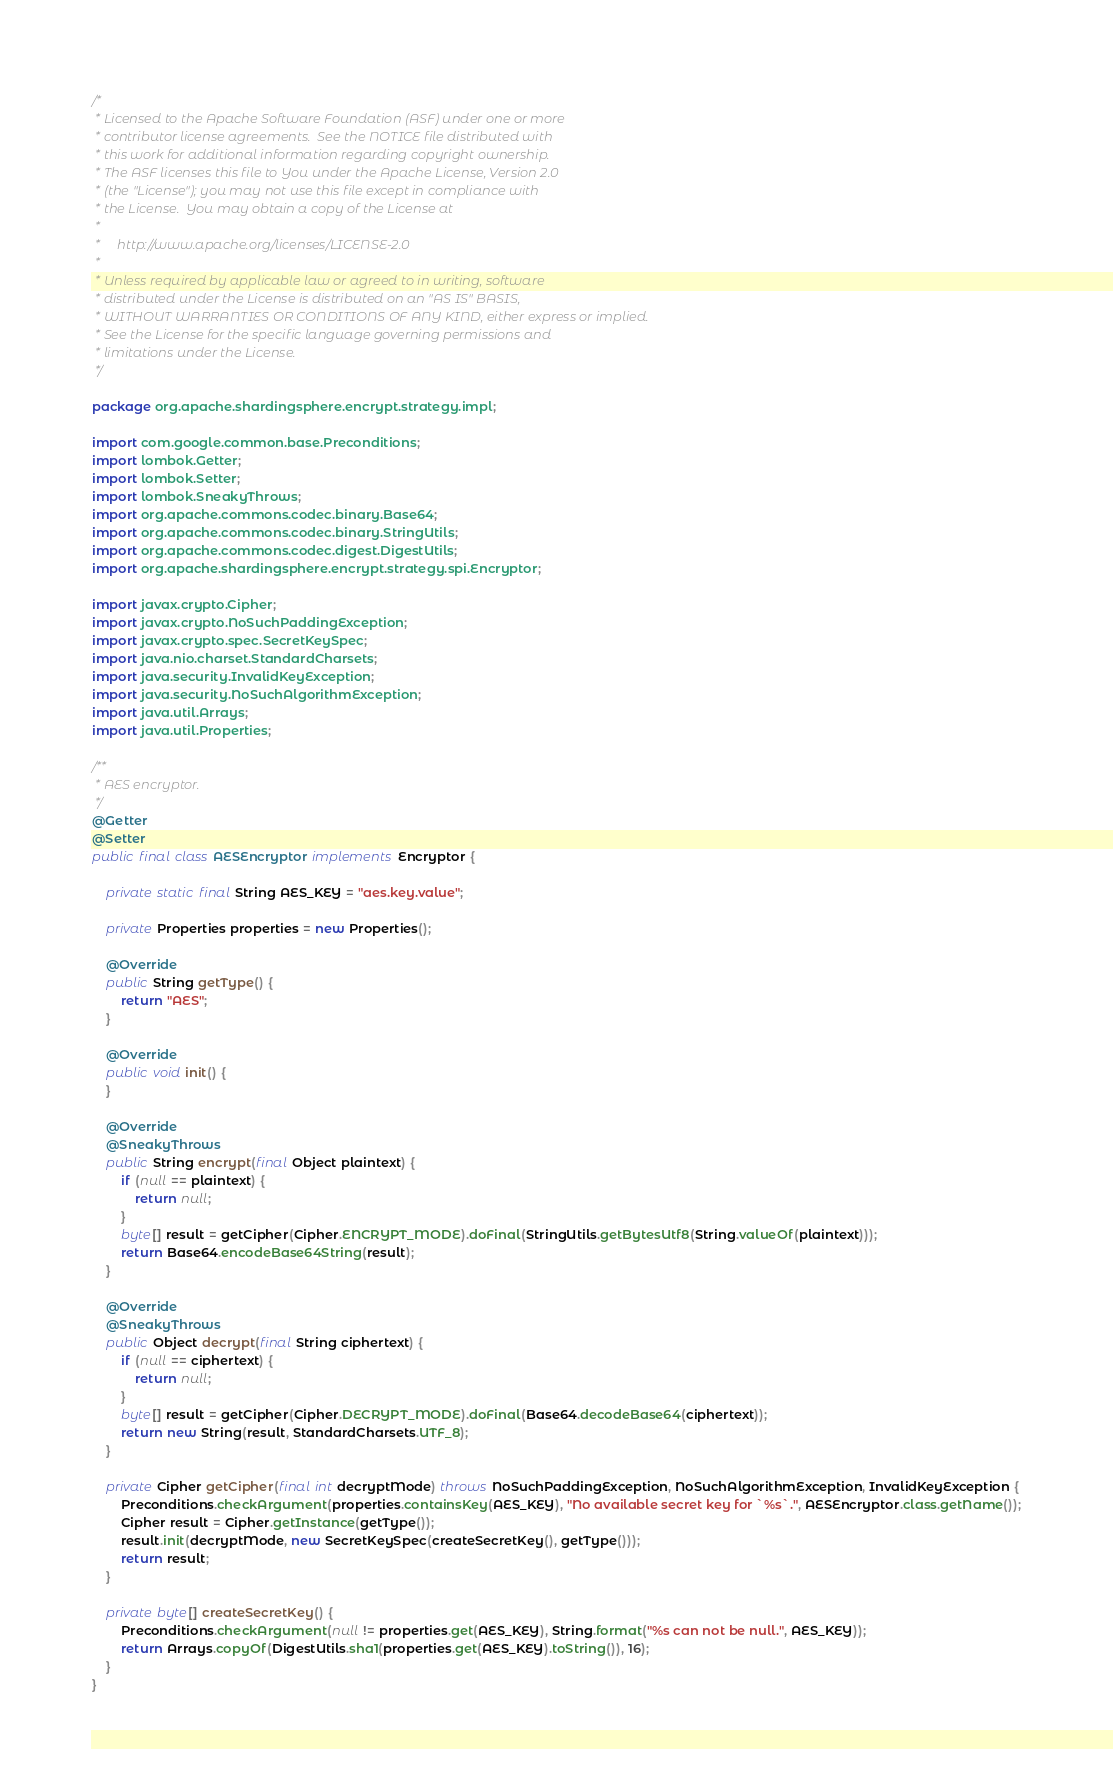Convert code to text. <code><loc_0><loc_0><loc_500><loc_500><_Java_>/*
 * Licensed to the Apache Software Foundation (ASF) under one or more
 * contributor license agreements.  See the NOTICE file distributed with
 * this work for additional information regarding copyright ownership.
 * The ASF licenses this file to You under the Apache License, Version 2.0
 * (the "License"); you may not use this file except in compliance with
 * the License.  You may obtain a copy of the License at
 *
 *     http://www.apache.org/licenses/LICENSE-2.0
 *
 * Unless required by applicable law or agreed to in writing, software
 * distributed under the License is distributed on an "AS IS" BASIS,
 * WITHOUT WARRANTIES OR CONDITIONS OF ANY KIND, either express or implied.
 * See the License for the specific language governing permissions and
 * limitations under the License.
 */

package org.apache.shardingsphere.encrypt.strategy.impl;

import com.google.common.base.Preconditions;
import lombok.Getter;
import lombok.Setter;
import lombok.SneakyThrows;
import org.apache.commons.codec.binary.Base64;
import org.apache.commons.codec.binary.StringUtils;
import org.apache.commons.codec.digest.DigestUtils;
import org.apache.shardingsphere.encrypt.strategy.spi.Encryptor;

import javax.crypto.Cipher;
import javax.crypto.NoSuchPaddingException;
import javax.crypto.spec.SecretKeySpec;
import java.nio.charset.StandardCharsets;
import java.security.InvalidKeyException;
import java.security.NoSuchAlgorithmException;
import java.util.Arrays;
import java.util.Properties;

/**
 * AES encryptor.
 */
@Getter
@Setter
public final class AESEncryptor implements Encryptor {

    private static final String AES_KEY = "aes.key.value";

    private Properties properties = new Properties();

    @Override
    public String getType() {
        return "AES";
    }

    @Override
    public void init() {
    }

    @Override
    @SneakyThrows
    public String encrypt(final Object plaintext) {
        if (null == plaintext) {
            return null;
        }
        byte[] result = getCipher(Cipher.ENCRYPT_MODE).doFinal(StringUtils.getBytesUtf8(String.valueOf(plaintext)));
        return Base64.encodeBase64String(result);
    }

    @Override
    @SneakyThrows
    public Object decrypt(final String ciphertext) {
        if (null == ciphertext) {
            return null;
        }
        byte[] result = getCipher(Cipher.DECRYPT_MODE).doFinal(Base64.decodeBase64(ciphertext));
        return new String(result, StandardCharsets.UTF_8);
    }

    private Cipher getCipher(final int decryptMode) throws NoSuchPaddingException, NoSuchAlgorithmException, InvalidKeyException {
        Preconditions.checkArgument(properties.containsKey(AES_KEY), "No available secret key for `%s`.", AESEncryptor.class.getName());
        Cipher result = Cipher.getInstance(getType());
        result.init(decryptMode, new SecretKeySpec(createSecretKey(), getType()));
        return result;
    }

    private byte[] createSecretKey() {
        Preconditions.checkArgument(null != properties.get(AES_KEY), String.format("%s can not be null.", AES_KEY));
        return Arrays.copyOf(DigestUtils.sha1(properties.get(AES_KEY).toString()), 16);
    }
}
</code> 